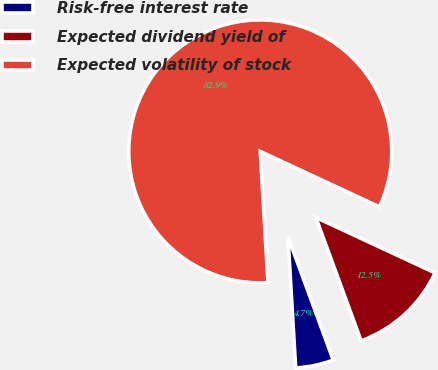<chart> <loc_0><loc_0><loc_500><loc_500><pie_chart><fcel>Risk-free interest rate<fcel>Expected dividend yield of<fcel>Expected volatility of stock<nl><fcel>4.66%<fcel>12.47%<fcel>82.86%<nl></chart> 